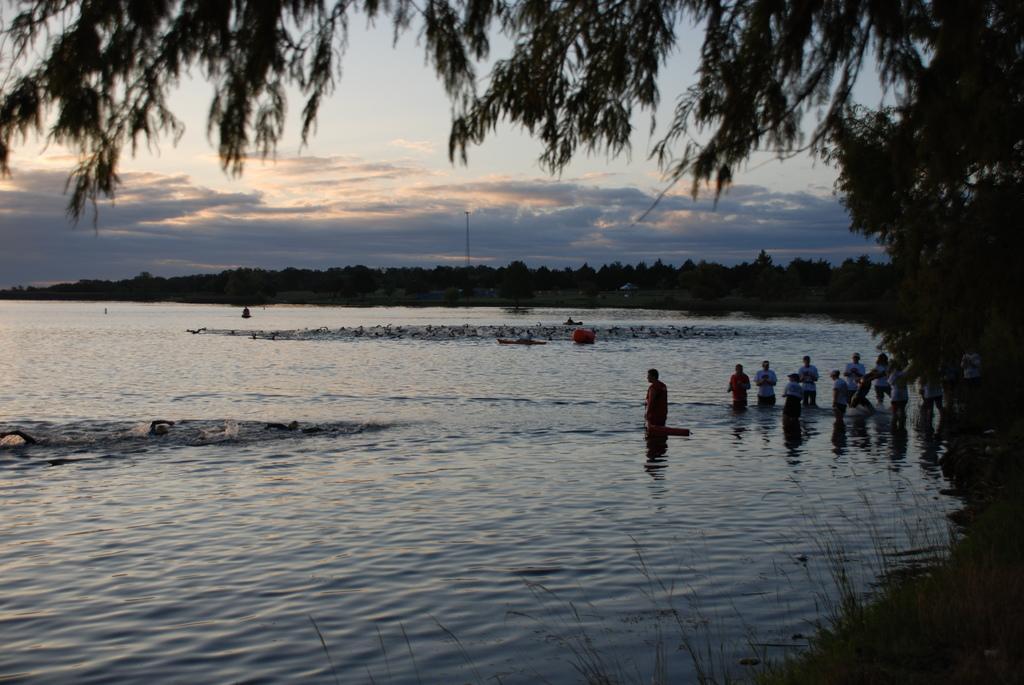Could you give a brief overview of what you see in this image? In this image we can see a few people in the water, there are some trees, grass, boats and a pole, in the background, we can see the sky with clouds. 